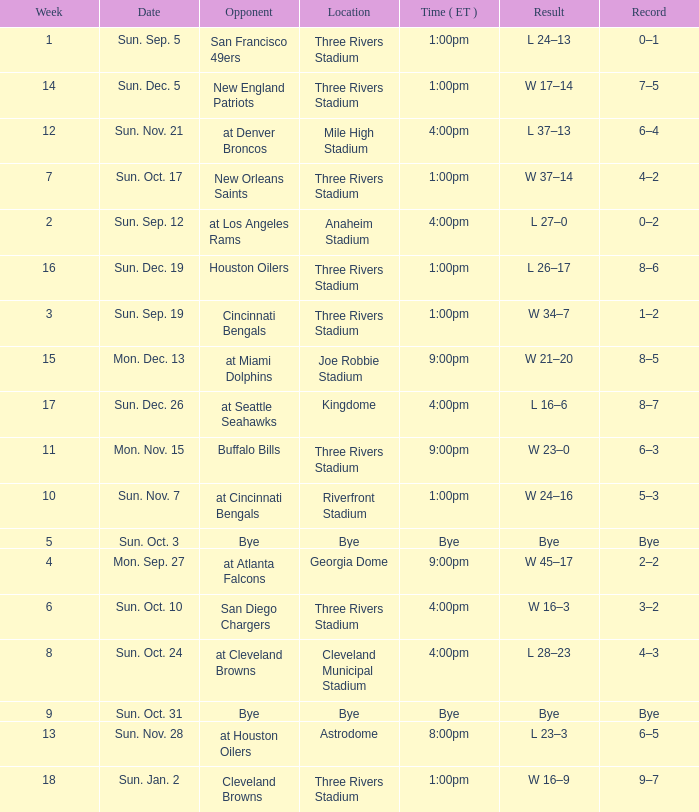What is the average Week for the game at three rivers stadium, with a Record of 3–2? 6.0. 